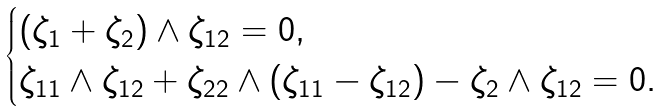Convert formula to latex. <formula><loc_0><loc_0><loc_500><loc_500>\begin{cases} ( \zeta _ { 1 } + \zeta _ { 2 } ) \wedge \zeta _ { 1 2 } = 0 , \\ \zeta _ { 1 1 } \wedge \zeta _ { 1 2 } + \zeta _ { 2 2 } \wedge ( \zeta _ { 1 1 } - \zeta _ { 1 2 } ) - \zeta _ { 2 } \wedge \zeta _ { 1 2 } = 0 . \end{cases}</formula> 